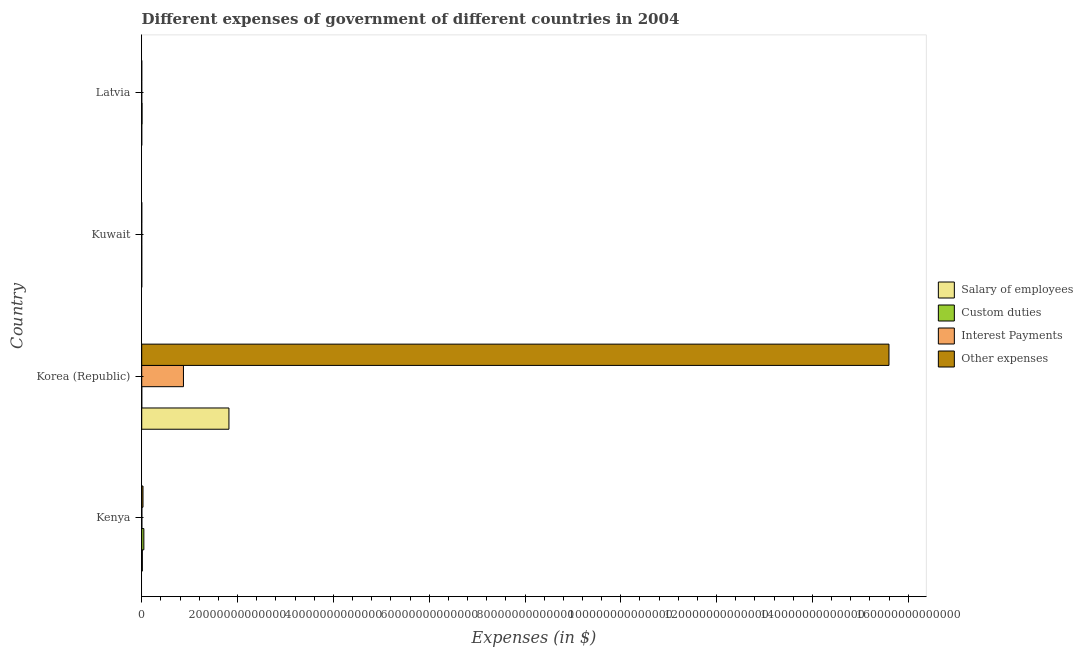How many different coloured bars are there?
Offer a terse response. 4. How many bars are there on the 2nd tick from the top?
Give a very brief answer. 4. In how many cases, is the number of bars for a given country not equal to the number of legend labels?
Give a very brief answer. 0. What is the amount spent on other expenses in Latvia?
Offer a terse response. 2.06e+09. Across all countries, what is the maximum amount spent on interest payments?
Your answer should be very brief. 8.71e+12. Across all countries, what is the minimum amount spent on interest payments?
Offer a very short reply. 1.30e+07. In which country was the amount spent on salary of employees maximum?
Provide a short and direct response. Korea (Republic). In which country was the amount spent on interest payments minimum?
Your answer should be compact. Kuwait. What is the total amount spent on custom duties in the graph?
Your response must be concise. 5.18e+11. What is the difference between the amount spent on salary of employees in Korea (Republic) and that in Latvia?
Give a very brief answer. 1.82e+13. What is the difference between the amount spent on interest payments in Latvia and the amount spent on other expenses in Kenya?
Provide a succinct answer. -2.66e+11. What is the average amount spent on salary of employees per country?
Provide a short and direct response. 4.58e+12. What is the difference between the amount spent on custom duties and amount spent on interest payments in Kenya?
Your response must be concise. 4.17e+11. What is the ratio of the amount spent on interest payments in Korea (Republic) to that in Kuwait?
Make the answer very short. 6.70e+05. Is the difference between the amount spent on interest payments in Kenya and Latvia greater than the difference between the amount spent on custom duties in Kenya and Latvia?
Offer a very short reply. No. What is the difference between the highest and the second highest amount spent on interest payments?
Ensure brevity in your answer.  8.68e+12. What is the difference between the highest and the lowest amount spent on custom duties?
Your answer should be compact. 4.44e+11. What does the 2nd bar from the top in Latvia represents?
Give a very brief answer. Interest Payments. What does the 2nd bar from the bottom in Kenya represents?
Offer a terse response. Custom duties. Is it the case that in every country, the sum of the amount spent on salary of employees and amount spent on custom duties is greater than the amount spent on interest payments?
Your response must be concise. Yes. How many bars are there?
Your response must be concise. 16. How many countries are there in the graph?
Make the answer very short. 4. What is the difference between two consecutive major ticks on the X-axis?
Your answer should be compact. 2.00e+13. Does the graph contain any zero values?
Your response must be concise. No. Does the graph contain grids?
Ensure brevity in your answer.  No. How are the legend labels stacked?
Offer a very short reply. Vertical. What is the title of the graph?
Provide a succinct answer. Different expenses of government of different countries in 2004. Does "Source data assessment" appear as one of the legend labels in the graph?
Ensure brevity in your answer.  No. What is the label or title of the X-axis?
Your response must be concise. Expenses (in $). What is the Expenses (in $) of Salary of employees in Kenya?
Ensure brevity in your answer.  1.32e+11. What is the Expenses (in $) of Custom duties in Kenya?
Provide a short and direct response. 4.45e+11. What is the Expenses (in $) in Interest Payments in Kenya?
Your response must be concise. 2.77e+1. What is the Expenses (in $) of Other expenses in Kenya?
Your answer should be compact. 2.66e+11. What is the Expenses (in $) of Salary of employees in Korea (Republic)?
Give a very brief answer. 1.82e+13. What is the Expenses (in $) of Custom duties in Korea (Republic)?
Offer a very short reply. 3.87e+09. What is the Expenses (in $) of Interest Payments in Korea (Republic)?
Your answer should be very brief. 8.71e+12. What is the Expenses (in $) in Other expenses in Korea (Republic)?
Offer a very short reply. 1.56e+14. What is the Expenses (in $) in Salary of employees in Kuwait?
Give a very brief answer. 1.62e+09. What is the Expenses (in $) of Custom duties in Kuwait?
Provide a succinct answer. 1.14e+09. What is the Expenses (in $) of Interest Payments in Kuwait?
Offer a very short reply. 1.30e+07. What is the Expenses (in $) in Other expenses in Kuwait?
Keep it short and to the point. 5.63e+09. What is the Expenses (in $) in Salary of employees in Latvia?
Ensure brevity in your answer.  3.35e+08. What is the Expenses (in $) of Custom duties in Latvia?
Provide a short and direct response. 6.76e+1. What is the Expenses (in $) in Other expenses in Latvia?
Give a very brief answer. 2.06e+09. Across all countries, what is the maximum Expenses (in $) in Salary of employees?
Make the answer very short. 1.82e+13. Across all countries, what is the maximum Expenses (in $) in Custom duties?
Provide a short and direct response. 4.45e+11. Across all countries, what is the maximum Expenses (in $) in Interest Payments?
Make the answer very short. 8.71e+12. Across all countries, what is the maximum Expenses (in $) in Other expenses?
Your response must be concise. 1.56e+14. Across all countries, what is the minimum Expenses (in $) of Salary of employees?
Your response must be concise. 3.35e+08. Across all countries, what is the minimum Expenses (in $) in Custom duties?
Keep it short and to the point. 1.14e+09. Across all countries, what is the minimum Expenses (in $) of Interest Payments?
Give a very brief answer. 1.30e+07. Across all countries, what is the minimum Expenses (in $) in Other expenses?
Offer a very short reply. 2.06e+09. What is the total Expenses (in $) in Salary of employees in the graph?
Ensure brevity in your answer.  1.83e+13. What is the total Expenses (in $) of Custom duties in the graph?
Your answer should be compact. 5.18e+11. What is the total Expenses (in $) in Interest Payments in the graph?
Make the answer very short. 8.74e+12. What is the total Expenses (in $) in Other expenses in the graph?
Ensure brevity in your answer.  1.56e+14. What is the difference between the Expenses (in $) in Salary of employees in Kenya and that in Korea (Republic)?
Offer a very short reply. -1.81e+13. What is the difference between the Expenses (in $) in Custom duties in Kenya and that in Korea (Republic)?
Give a very brief answer. 4.41e+11. What is the difference between the Expenses (in $) of Interest Payments in Kenya and that in Korea (Republic)?
Ensure brevity in your answer.  -8.68e+12. What is the difference between the Expenses (in $) of Other expenses in Kenya and that in Korea (Republic)?
Offer a terse response. -1.56e+14. What is the difference between the Expenses (in $) of Salary of employees in Kenya and that in Kuwait?
Make the answer very short. 1.30e+11. What is the difference between the Expenses (in $) of Custom duties in Kenya and that in Kuwait?
Make the answer very short. 4.44e+11. What is the difference between the Expenses (in $) in Interest Payments in Kenya and that in Kuwait?
Provide a succinct answer. 2.77e+1. What is the difference between the Expenses (in $) of Other expenses in Kenya and that in Kuwait?
Offer a very short reply. 2.60e+11. What is the difference between the Expenses (in $) in Salary of employees in Kenya and that in Latvia?
Offer a terse response. 1.31e+11. What is the difference between the Expenses (in $) in Custom duties in Kenya and that in Latvia?
Provide a short and direct response. 3.77e+11. What is the difference between the Expenses (in $) in Interest Payments in Kenya and that in Latvia?
Your answer should be very brief. 2.77e+1. What is the difference between the Expenses (in $) of Other expenses in Kenya and that in Latvia?
Ensure brevity in your answer.  2.64e+11. What is the difference between the Expenses (in $) in Salary of employees in Korea (Republic) and that in Kuwait?
Provide a short and direct response. 1.82e+13. What is the difference between the Expenses (in $) in Custom duties in Korea (Republic) and that in Kuwait?
Provide a short and direct response. 2.74e+09. What is the difference between the Expenses (in $) of Interest Payments in Korea (Republic) and that in Kuwait?
Your response must be concise. 8.71e+12. What is the difference between the Expenses (in $) in Other expenses in Korea (Republic) and that in Kuwait?
Ensure brevity in your answer.  1.56e+14. What is the difference between the Expenses (in $) of Salary of employees in Korea (Republic) and that in Latvia?
Ensure brevity in your answer.  1.82e+13. What is the difference between the Expenses (in $) in Custom duties in Korea (Republic) and that in Latvia?
Offer a very short reply. -6.37e+1. What is the difference between the Expenses (in $) in Interest Payments in Korea (Republic) and that in Latvia?
Provide a succinct answer. 8.71e+12. What is the difference between the Expenses (in $) in Other expenses in Korea (Republic) and that in Latvia?
Your answer should be compact. 1.56e+14. What is the difference between the Expenses (in $) in Salary of employees in Kuwait and that in Latvia?
Offer a very short reply. 1.29e+09. What is the difference between the Expenses (in $) of Custom duties in Kuwait and that in Latvia?
Offer a very short reply. -6.65e+1. What is the difference between the Expenses (in $) of Interest Payments in Kuwait and that in Latvia?
Your response must be concise. -3.70e+07. What is the difference between the Expenses (in $) of Other expenses in Kuwait and that in Latvia?
Offer a very short reply. 3.57e+09. What is the difference between the Expenses (in $) of Salary of employees in Kenya and the Expenses (in $) of Custom duties in Korea (Republic)?
Your answer should be compact. 1.28e+11. What is the difference between the Expenses (in $) of Salary of employees in Kenya and the Expenses (in $) of Interest Payments in Korea (Republic)?
Offer a terse response. -8.58e+12. What is the difference between the Expenses (in $) in Salary of employees in Kenya and the Expenses (in $) in Other expenses in Korea (Republic)?
Your answer should be compact. -1.56e+14. What is the difference between the Expenses (in $) of Custom duties in Kenya and the Expenses (in $) of Interest Payments in Korea (Republic)?
Give a very brief answer. -8.27e+12. What is the difference between the Expenses (in $) of Custom duties in Kenya and the Expenses (in $) of Other expenses in Korea (Republic)?
Keep it short and to the point. -1.56e+14. What is the difference between the Expenses (in $) in Interest Payments in Kenya and the Expenses (in $) in Other expenses in Korea (Republic)?
Provide a succinct answer. -1.56e+14. What is the difference between the Expenses (in $) in Salary of employees in Kenya and the Expenses (in $) in Custom duties in Kuwait?
Your answer should be compact. 1.31e+11. What is the difference between the Expenses (in $) in Salary of employees in Kenya and the Expenses (in $) in Interest Payments in Kuwait?
Ensure brevity in your answer.  1.32e+11. What is the difference between the Expenses (in $) of Salary of employees in Kenya and the Expenses (in $) of Other expenses in Kuwait?
Offer a very short reply. 1.26e+11. What is the difference between the Expenses (in $) of Custom duties in Kenya and the Expenses (in $) of Interest Payments in Kuwait?
Provide a succinct answer. 4.45e+11. What is the difference between the Expenses (in $) of Custom duties in Kenya and the Expenses (in $) of Other expenses in Kuwait?
Ensure brevity in your answer.  4.39e+11. What is the difference between the Expenses (in $) of Interest Payments in Kenya and the Expenses (in $) of Other expenses in Kuwait?
Provide a short and direct response. 2.21e+1. What is the difference between the Expenses (in $) of Salary of employees in Kenya and the Expenses (in $) of Custom duties in Latvia?
Your response must be concise. 6.41e+1. What is the difference between the Expenses (in $) of Salary of employees in Kenya and the Expenses (in $) of Interest Payments in Latvia?
Give a very brief answer. 1.32e+11. What is the difference between the Expenses (in $) of Salary of employees in Kenya and the Expenses (in $) of Other expenses in Latvia?
Make the answer very short. 1.30e+11. What is the difference between the Expenses (in $) of Custom duties in Kenya and the Expenses (in $) of Interest Payments in Latvia?
Make the answer very short. 4.45e+11. What is the difference between the Expenses (in $) in Custom duties in Kenya and the Expenses (in $) in Other expenses in Latvia?
Your answer should be compact. 4.43e+11. What is the difference between the Expenses (in $) in Interest Payments in Kenya and the Expenses (in $) in Other expenses in Latvia?
Provide a succinct answer. 2.57e+1. What is the difference between the Expenses (in $) in Salary of employees in Korea (Republic) and the Expenses (in $) in Custom duties in Kuwait?
Your answer should be very brief. 1.82e+13. What is the difference between the Expenses (in $) of Salary of employees in Korea (Republic) and the Expenses (in $) of Interest Payments in Kuwait?
Offer a very short reply. 1.82e+13. What is the difference between the Expenses (in $) of Salary of employees in Korea (Republic) and the Expenses (in $) of Other expenses in Kuwait?
Offer a terse response. 1.82e+13. What is the difference between the Expenses (in $) in Custom duties in Korea (Republic) and the Expenses (in $) in Interest Payments in Kuwait?
Provide a short and direct response. 3.86e+09. What is the difference between the Expenses (in $) in Custom duties in Korea (Republic) and the Expenses (in $) in Other expenses in Kuwait?
Provide a succinct answer. -1.76e+09. What is the difference between the Expenses (in $) in Interest Payments in Korea (Republic) and the Expenses (in $) in Other expenses in Kuwait?
Provide a short and direct response. 8.70e+12. What is the difference between the Expenses (in $) of Salary of employees in Korea (Republic) and the Expenses (in $) of Custom duties in Latvia?
Your answer should be very brief. 1.81e+13. What is the difference between the Expenses (in $) of Salary of employees in Korea (Republic) and the Expenses (in $) of Interest Payments in Latvia?
Offer a terse response. 1.82e+13. What is the difference between the Expenses (in $) of Salary of employees in Korea (Republic) and the Expenses (in $) of Other expenses in Latvia?
Offer a very short reply. 1.82e+13. What is the difference between the Expenses (in $) in Custom duties in Korea (Republic) and the Expenses (in $) in Interest Payments in Latvia?
Offer a very short reply. 3.82e+09. What is the difference between the Expenses (in $) in Custom duties in Korea (Republic) and the Expenses (in $) in Other expenses in Latvia?
Provide a succinct answer. 1.81e+09. What is the difference between the Expenses (in $) in Interest Payments in Korea (Republic) and the Expenses (in $) in Other expenses in Latvia?
Offer a very short reply. 8.71e+12. What is the difference between the Expenses (in $) in Salary of employees in Kuwait and the Expenses (in $) in Custom duties in Latvia?
Your response must be concise. -6.60e+1. What is the difference between the Expenses (in $) of Salary of employees in Kuwait and the Expenses (in $) of Interest Payments in Latvia?
Ensure brevity in your answer.  1.58e+09. What is the difference between the Expenses (in $) in Salary of employees in Kuwait and the Expenses (in $) in Other expenses in Latvia?
Your response must be concise. -4.39e+08. What is the difference between the Expenses (in $) of Custom duties in Kuwait and the Expenses (in $) of Interest Payments in Latvia?
Offer a very short reply. 1.09e+09. What is the difference between the Expenses (in $) of Custom duties in Kuwait and the Expenses (in $) of Other expenses in Latvia?
Provide a succinct answer. -9.28e+08. What is the difference between the Expenses (in $) of Interest Payments in Kuwait and the Expenses (in $) of Other expenses in Latvia?
Offer a terse response. -2.05e+09. What is the average Expenses (in $) of Salary of employees per country?
Ensure brevity in your answer.  4.58e+12. What is the average Expenses (in $) of Custom duties per country?
Your answer should be compact. 1.29e+11. What is the average Expenses (in $) in Interest Payments per country?
Provide a short and direct response. 2.18e+12. What is the average Expenses (in $) in Other expenses per country?
Ensure brevity in your answer.  3.91e+13. What is the difference between the Expenses (in $) of Salary of employees and Expenses (in $) of Custom duties in Kenya?
Ensure brevity in your answer.  -3.13e+11. What is the difference between the Expenses (in $) of Salary of employees and Expenses (in $) of Interest Payments in Kenya?
Offer a very short reply. 1.04e+11. What is the difference between the Expenses (in $) in Salary of employees and Expenses (in $) in Other expenses in Kenya?
Offer a terse response. -1.34e+11. What is the difference between the Expenses (in $) of Custom duties and Expenses (in $) of Interest Payments in Kenya?
Your answer should be very brief. 4.17e+11. What is the difference between the Expenses (in $) in Custom duties and Expenses (in $) in Other expenses in Kenya?
Provide a succinct answer. 1.79e+11. What is the difference between the Expenses (in $) of Interest Payments and Expenses (in $) of Other expenses in Kenya?
Your answer should be very brief. -2.38e+11. What is the difference between the Expenses (in $) of Salary of employees and Expenses (in $) of Custom duties in Korea (Republic)?
Your response must be concise. 1.82e+13. What is the difference between the Expenses (in $) of Salary of employees and Expenses (in $) of Interest Payments in Korea (Republic)?
Provide a succinct answer. 9.50e+12. What is the difference between the Expenses (in $) in Salary of employees and Expenses (in $) in Other expenses in Korea (Republic)?
Your answer should be compact. -1.38e+14. What is the difference between the Expenses (in $) of Custom duties and Expenses (in $) of Interest Payments in Korea (Republic)?
Provide a succinct answer. -8.71e+12. What is the difference between the Expenses (in $) of Custom duties and Expenses (in $) of Other expenses in Korea (Republic)?
Ensure brevity in your answer.  -1.56e+14. What is the difference between the Expenses (in $) of Interest Payments and Expenses (in $) of Other expenses in Korea (Republic)?
Make the answer very short. -1.47e+14. What is the difference between the Expenses (in $) of Salary of employees and Expenses (in $) of Custom duties in Kuwait?
Make the answer very short. 4.89e+08. What is the difference between the Expenses (in $) of Salary of employees and Expenses (in $) of Interest Payments in Kuwait?
Give a very brief answer. 1.61e+09. What is the difference between the Expenses (in $) of Salary of employees and Expenses (in $) of Other expenses in Kuwait?
Your response must be concise. -4.01e+09. What is the difference between the Expenses (in $) in Custom duties and Expenses (in $) in Interest Payments in Kuwait?
Keep it short and to the point. 1.12e+09. What is the difference between the Expenses (in $) in Custom duties and Expenses (in $) in Other expenses in Kuwait?
Provide a succinct answer. -4.50e+09. What is the difference between the Expenses (in $) in Interest Payments and Expenses (in $) in Other expenses in Kuwait?
Offer a terse response. -5.62e+09. What is the difference between the Expenses (in $) in Salary of employees and Expenses (in $) in Custom duties in Latvia?
Your answer should be compact. -6.73e+1. What is the difference between the Expenses (in $) of Salary of employees and Expenses (in $) of Interest Payments in Latvia?
Provide a succinct answer. 2.85e+08. What is the difference between the Expenses (in $) of Salary of employees and Expenses (in $) of Other expenses in Latvia?
Keep it short and to the point. -1.73e+09. What is the difference between the Expenses (in $) in Custom duties and Expenses (in $) in Interest Payments in Latvia?
Offer a terse response. 6.75e+1. What is the difference between the Expenses (in $) of Custom duties and Expenses (in $) of Other expenses in Latvia?
Your answer should be very brief. 6.55e+1. What is the difference between the Expenses (in $) of Interest Payments and Expenses (in $) of Other expenses in Latvia?
Your answer should be compact. -2.01e+09. What is the ratio of the Expenses (in $) in Salary of employees in Kenya to that in Korea (Republic)?
Keep it short and to the point. 0.01. What is the ratio of the Expenses (in $) in Custom duties in Kenya to that in Korea (Republic)?
Offer a very short reply. 114.85. What is the ratio of the Expenses (in $) of Interest Payments in Kenya to that in Korea (Republic)?
Provide a short and direct response. 0. What is the ratio of the Expenses (in $) in Other expenses in Kenya to that in Korea (Republic)?
Offer a very short reply. 0. What is the ratio of the Expenses (in $) of Salary of employees in Kenya to that in Kuwait?
Ensure brevity in your answer.  81.03. What is the ratio of the Expenses (in $) of Custom duties in Kenya to that in Kuwait?
Give a very brief answer. 391.69. What is the ratio of the Expenses (in $) in Interest Payments in Kenya to that in Kuwait?
Your response must be concise. 2134.11. What is the ratio of the Expenses (in $) of Other expenses in Kenya to that in Kuwait?
Provide a succinct answer. 47.2. What is the ratio of the Expenses (in $) in Salary of employees in Kenya to that in Latvia?
Offer a very short reply. 392.58. What is the ratio of the Expenses (in $) in Custom duties in Kenya to that in Latvia?
Offer a very short reply. 6.58. What is the ratio of the Expenses (in $) of Interest Payments in Kenya to that in Latvia?
Keep it short and to the point. 554.87. What is the ratio of the Expenses (in $) of Other expenses in Kenya to that in Latvia?
Ensure brevity in your answer.  128.78. What is the ratio of the Expenses (in $) in Salary of employees in Korea (Republic) to that in Kuwait?
Make the answer very short. 1.12e+04. What is the ratio of the Expenses (in $) in Custom duties in Korea (Republic) to that in Kuwait?
Offer a terse response. 3.41. What is the ratio of the Expenses (in $) in Interest Payments in Korea (Republic) to that in Kuwait?
Provide a succinct answer. 6.70e+05. What is the ratio of the Expenses (in $) in Other expenses in Korea (Republic) to that in Kuwait?
Keep it short and to the point. 2.77e+04. What is the ratio of the Expenses (in $) of Salary of employees in Korea (Republic) to that in Latvia?
Your response must be concise. 5.43e+04. What is the ratio of the Expenses (in $) in Custom duties in Korea (Republic) to that in Latvia?
Give a very brief answer. 0.06. What is the ratio of the Expenses (in $) in Interest Payments in Korea (Republic) to that in Latvia?
Offer a very short reply. 1.74e+05. What is the ratio of the Expenses (in $) in Other expenses in Korea (Republic) to that in Latvia?
Provide a short and direct response. 7.56e+04. What is the ratio of the Expenses (in $) of Salary of employees in Kuwait to that in Latvia?
Your response must be concise. 4.84. What is the ratio of the Expenses (in $) in Custom duties in Kuwait to that in Latvia?
Keep it short and to the point. 0.02. What is the ratio of the Expenses (in $) in Interest Payments in Kuwait to that in Latvia?
Ensure brevity in your answer.  0.26. What is the ratio of the Expenses (in $) in Other expenses in Kuwait to that in Latvia?
Offer a very short reply. 2.73. What is the difference between the highest and the second highest Expenses (in $) in Salary of employees?
Give a very brief answer. 1.81e+13. What is the difference between the highest and the second highest Expenses (in $) of Custom duties?
Make the answer very short. 3.77e+11. What is the difference between the highest and the second highest Expenses (in $) of Interest Payments?
Your response must be concise. 8.68e+12. What is the difference between the highest and the second highest Expenses (in $) of Other expenses?
Offer a very short reply. 1.56e+14. What is the difference between the highest and the lowest Expenses (in $) in Salary of employees?
Keep it short and to the point. 1.82e+13. What is the difference between the highest and the lowest Expenses (in $) in Custom duties?
Your answer should be very brief. 4.44e+11. What is the difference between the highest and the lowest Expenses (in $) in Interest Payments?
Give a very brief answer. 8.71e+12. What is the difference between the highest and the lowest Expenses (in $) of Other expenses?
Ensure brevity in your answer.  1.56e+14. 